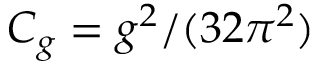Convert formula to latex. <formula><loc_0><loc_0><loc_500><loc_500>C _ { g } = g ^ { 2 } / ( 3 2 \pi ^ { 2 } )</formula> 